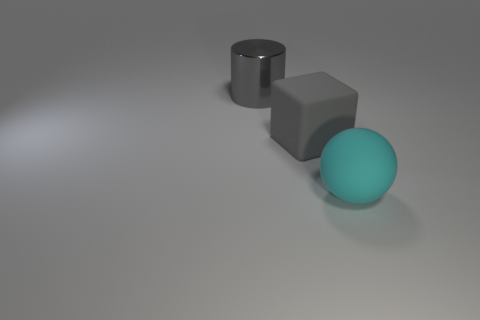Are the big cyan thing and the cylinder made of the same material? Based on the visual cues from the image, it's not certain if the cyan sphere and the cylinder are made of the same material due to the variance in their texture and reflections. The sphere has a smooth surface and reflects light differently compared to the cylinder's reflective metallic sheen, suggesting they could be composed of different substances or treated differently to achieve such appearances. 